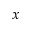Convert formula to latex. <formula><loc_0><loc_0><loc_500><loc_500>x</formula> 